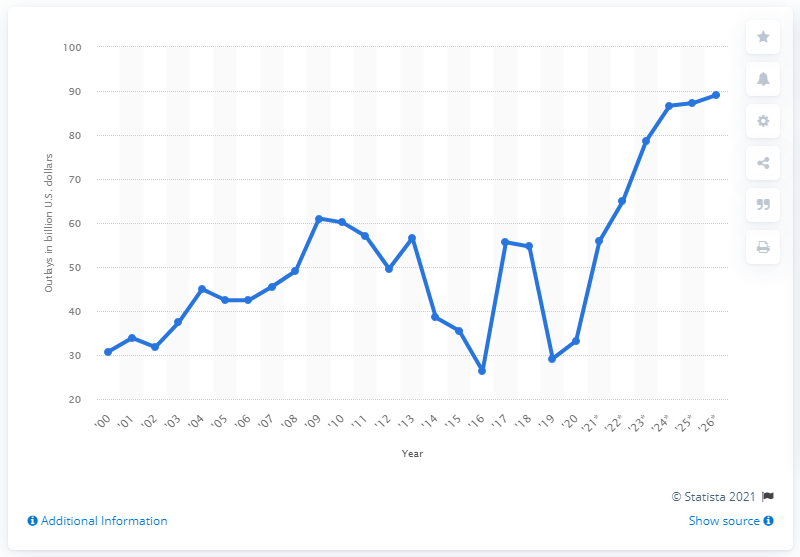Give some essential details in this illustration. The Department of Housing and Urban Development is expected to spend $89.08 by 2026. The Department of Housing and Urban Development spent $33.19 million in 2020. 